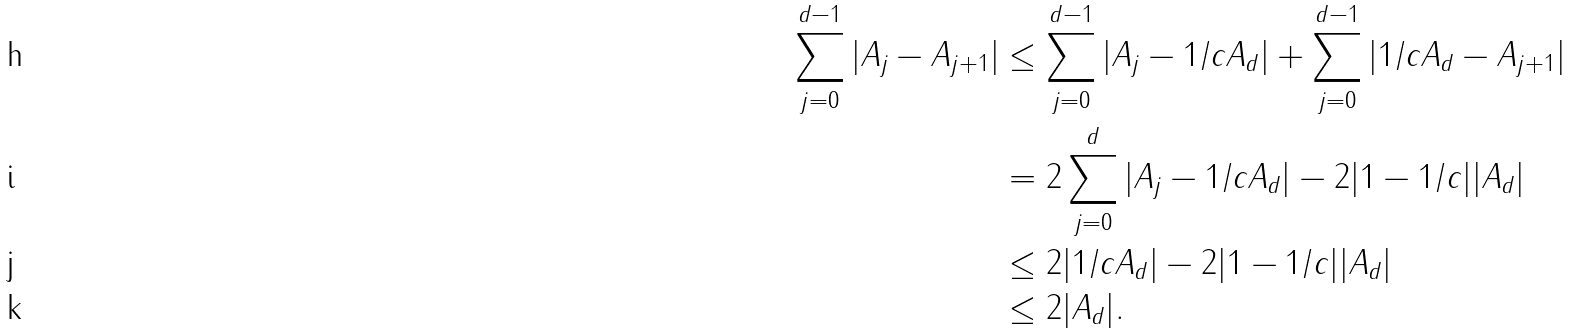<formula> <loc_0><loc_0><loc_500><loc_500>\sum _ { j = 0 } ^ { d - 1 } | A _ { j } - A _ { j + 1 } | & \leq \sum _ { j = 0 } ^ { d - 1 } | A _ { j } - 1 / c A _ { d } | + \sum _ { j = 0 } ^ { d - 1 } | 1 / c A _ { d } - A _ { j + 1 } | \\ & = 2 \sum _ { j = 0 } ^ { d } | A _ { j } - 1 / c A _ { d } | - 2 | 1 - 1 / c | | A _ { d } | \\ & \leq 2 | 1 / c A _ { d } | - 2 | 1 - 1 / c | | A _ { d } | \\ & \leq 2 | A _ { d } | .</formula> 